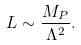Convert formula to latex. <formula><loc_0><loc_0><loc_500><loc_500>L \sim \frac { M _ { P } } { \Lambda ^ { 2 } } .</formula> 